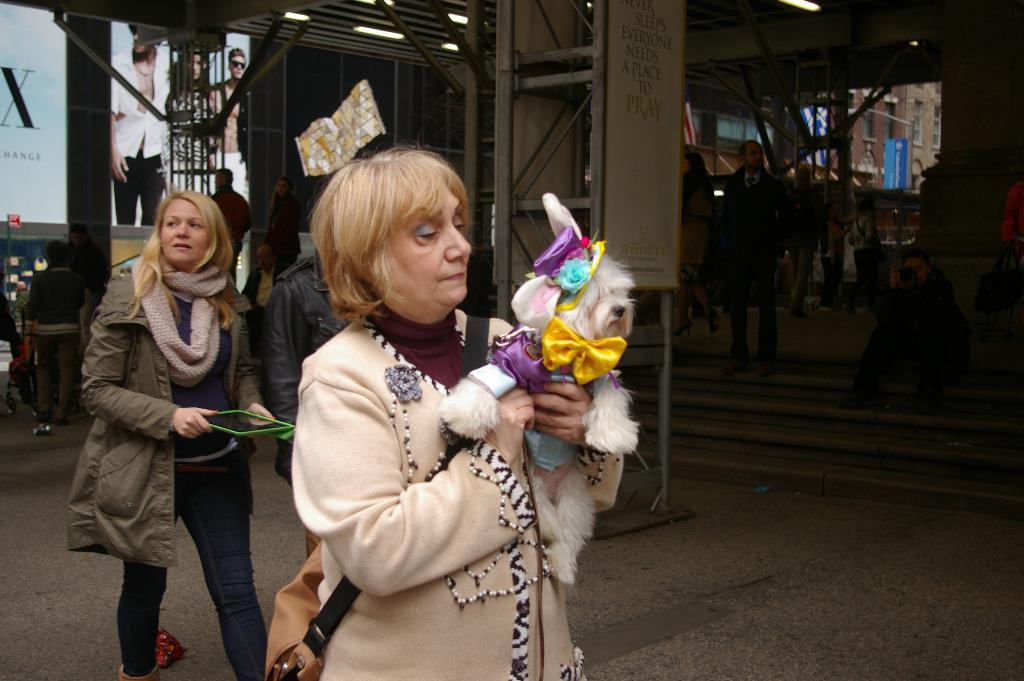How many people are in the image? There are people in the image, but the exact number is not specified. What is the woman in the image doing? The woman is holding a dog in her hands. What can be seen in the background of the image? There is a board and other objects on the ground in the background of the image. What is the purpose of the star in the image? There is no star present in the image, so it is not possible to determine its purpose. 